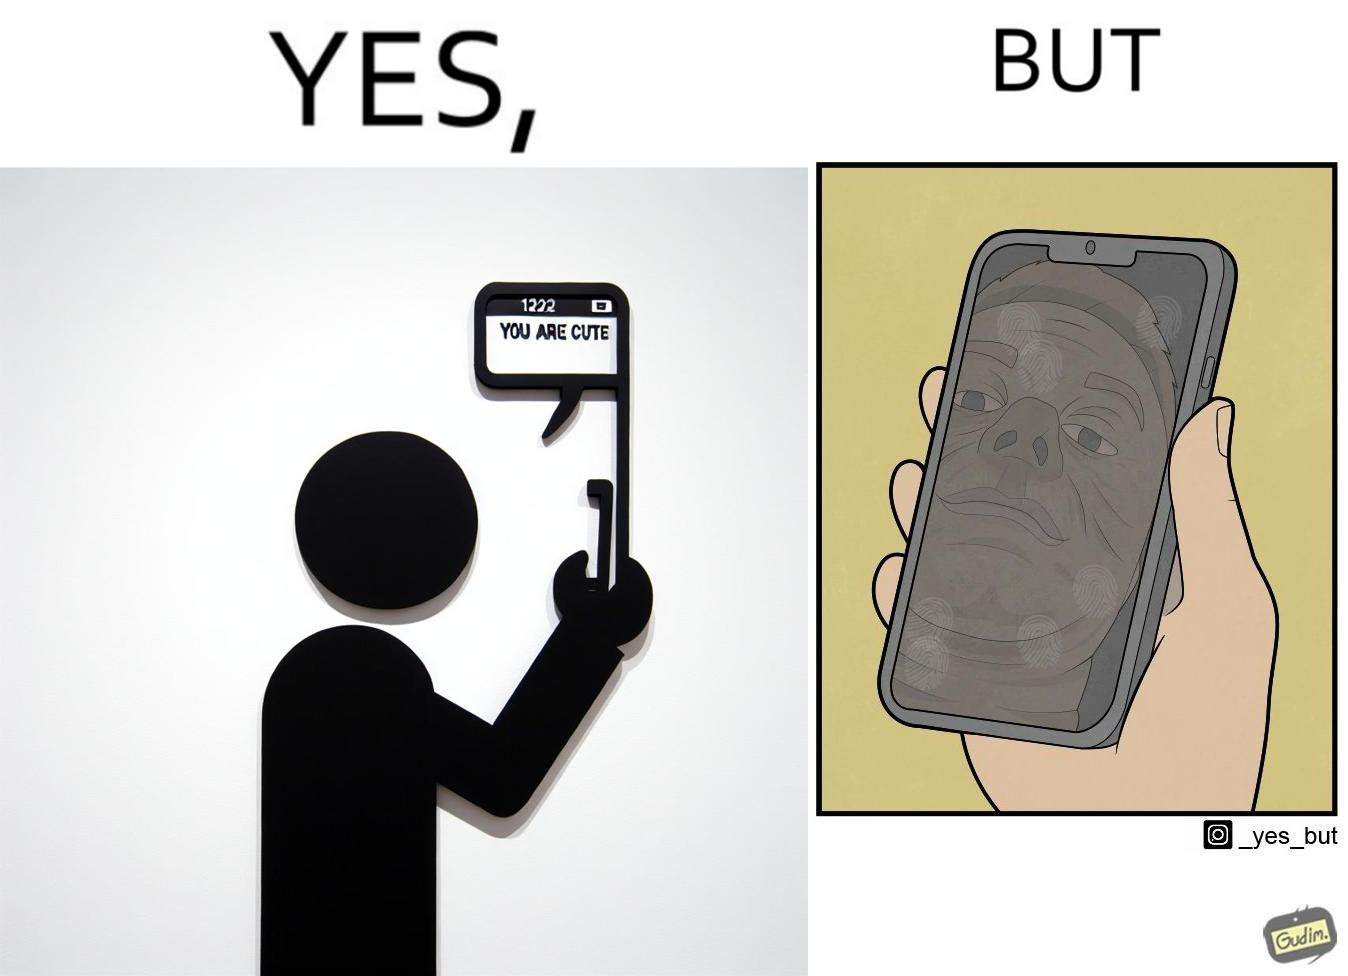What is shown in this image? The image is ironic, because person who received the text saying "you are cute" is apparently not good looking according to the beautyÃÂ standards 